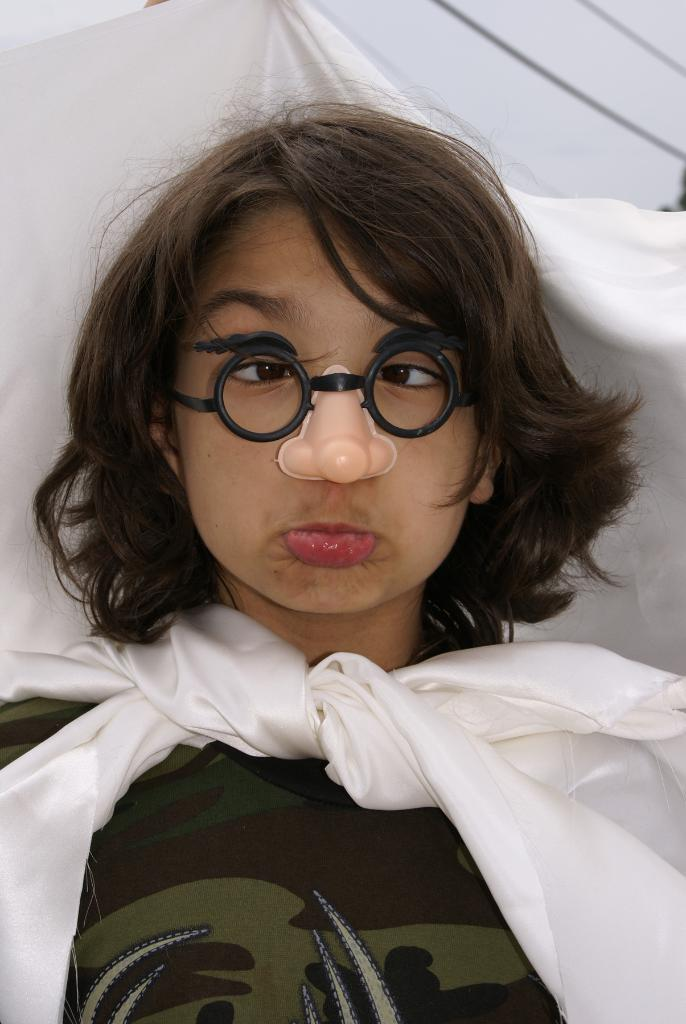Who or what is present in the image? There is a person in the image. What is the person wearing on their face? The person is wearing a nose mask. What type of eyewear is the person wearing? The person is wearing glasses. What is the person wearing that covers their upper body? The person is wearing a white cloth. What can be seen in the background of the image? There are wires and the sky visible in the background of the image. What type of cap is the person wearing in the image? There is no cap visible in the image; the person is wearing glasses, a nose mask, and a white cloth. How is the person distributing goods in the image? The image does not show the person distributing goods; it only shows the person wearing glasses, a nose mask, and a white cloth, with wires and the sky visible in the background. 